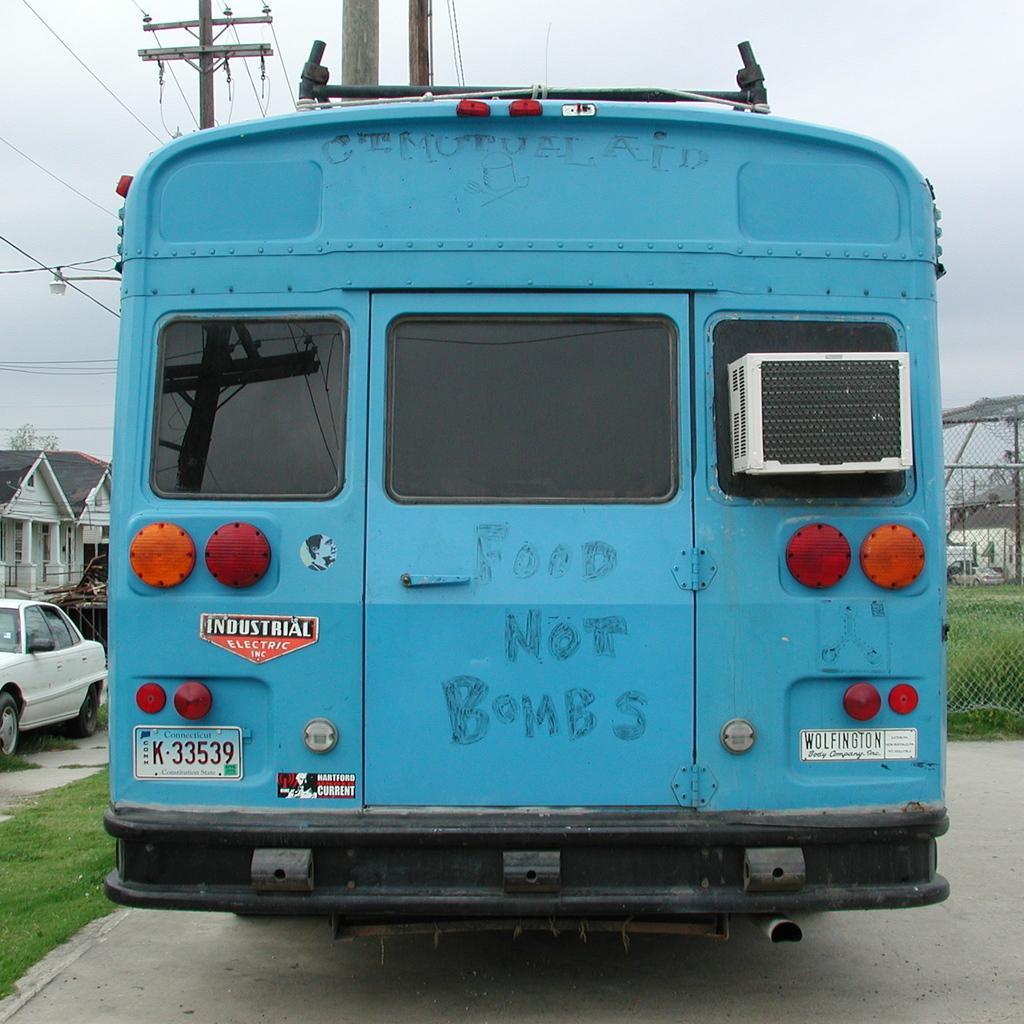Describe this image in one or two sentences. In this image, in the middle, we can see a vehicle which is in blue color. On the right side, we can see a net fence and few metal rods. On the left side, we can see a car, building, electric wires. In the background, we can also see some electrical wires. At the top, we can see a sky, at the bottom, we can see a grass and a road. 